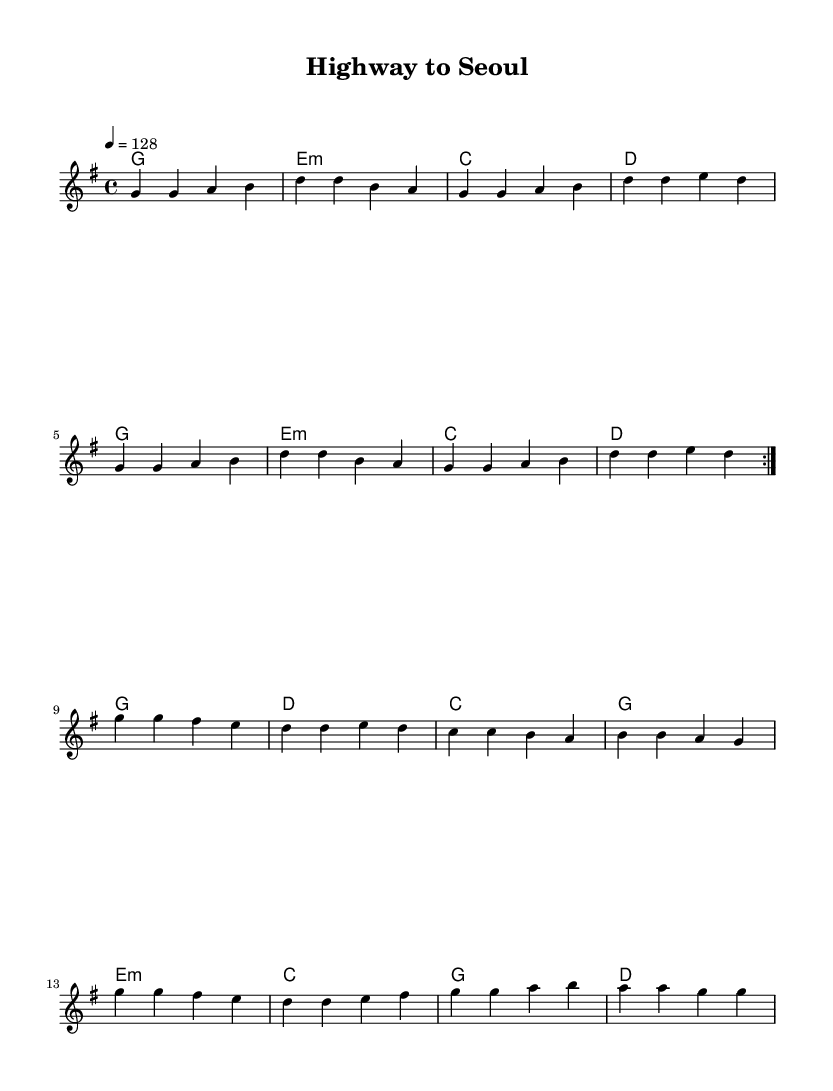What is the key signature of this music? The key signature is G major, which has one sharp (F#). You can tell by looking at the key signature at the beginning of the staff, which is placed after the clef symbol.
Answer: G major What is the time signature of this music? The time signature is 4/4, indicated by the numbers shown at the beginning of the staff. This means there are four beats in each measure and the quarter note gets one beat.
Answer: 4/4 What is the tempo marking for this piece? The tempo marking is 128 beats per minute, shown as "4 = 128" above the staff. This means the quarter note is played at a speed of 128 beats per minute.
Answer: 128 How many times is the first section repeated? The first section of the melody is repeated twice, indicated by the "volta" markings which show that the first part has to be played again before moving to the next section.
Answer: 2 What is the chord played in the first measure? The chord in the first measure is G major, indicated by the chord symbol "g" placed below the staff on the left side of the measure.
Answer: G major How does the rhythm of the melody primarily behave across consecutive measures? The rhythm mainly consists of eighth notes and quarter notes. This pattern is common in K-Pop for creating a lively and engaging feel. The rhythm adds to the high-energy vibe suitable for a road trip playlist.
Answer: Eighth and quarter notes What type of music is this sample representative of? This music is representative of K-Pop, which combines multiple genres and is characterized by high-energy beats, catchy melodies, and often includes strong dance rhythms that are perfect for engaging with during road trips.
Answer: K-Pop 